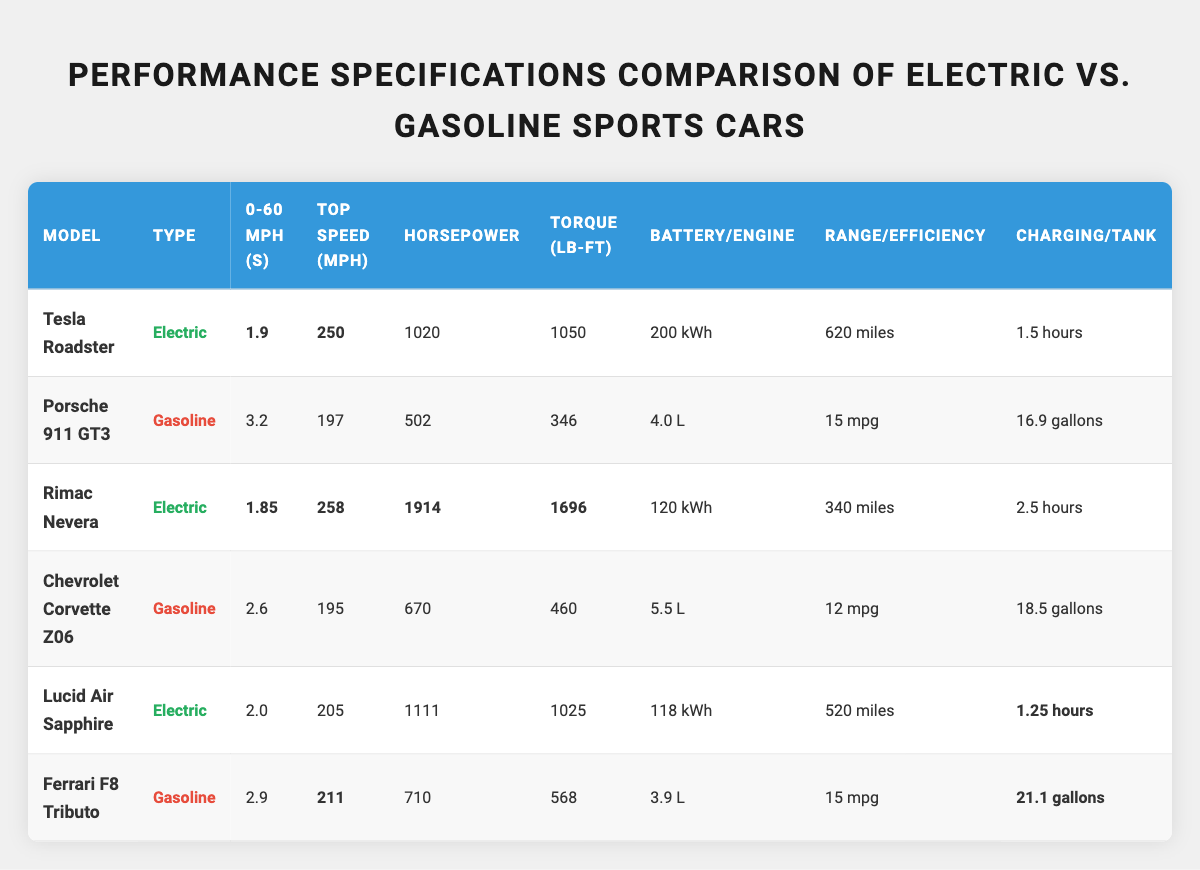What is the fastest 0-60 mph time among the cars? The table lists the 0-60 mph times for each model. The fastest time is for the Tesla Roadster at 1.9 seconds, followed closely by the Rimac Nevera at 1.85 seconds. Therefore, the fastest 0-60 mph time is 1.85 seconds.
Answer: 1.85 seconds Which car has the highest horsepower? By reviewing the horsepower values in the table, the Rimac Nevera has the highest horsepower at 1914. This is higher than the horsepower values of the Tesla Roadster (1020), Porsche 911 GT3 (502), Chevrolet Corvette Z06 (670), Lucid Air Sapphire (1111), and Ferrari F8 Tributo (710).
Answer: 1914 horsepower What is the torque difference between the Rimac Nevera and the Tesla Roadster? The Rimac Nevera has a torque of 1696 lb-ft, while the Tesla Roadster has a torque of 1050 lb-ft. To find the difference, subtract 1050 from 1696: 1696 - 1050 = 646.
Answer: 646 lb-ft Which type of car has the better range, electric or gasoline? Electric cars in the table, such as the Tesla Roadster (620 miles) and Lucid Air Sapphire (520 miles), have longer ranges compared to gasoline cars like Porsche 911 GT3 (15 mpg), Chevrolet Corvette Z06 (12 mpg), and Ferrari F8 Tributo (15 mpg), which do not have comparable range values.
Answer: Electric cars have better range What is the average 0-60 mph time of gasoline cars? The gasoline cars' 0-60 mph times are 3.2 seconds (Porsche 911 GT3), 2.6 seconds (Chevrolet Corvette Z06), and 2.9 seconds (Ferrari F8 Tributo). To find the average, sum these times (3.2 + 2.6 + 2.9 = 8.7) and divide by the number of cars (3): 8.7 / 3 = 2.9 seconds.
Answer: 2.9 seconds Which car has the shortest charging time? Reviewing the charging times in the table, the Lucid Air Sapphire has the shortest charging time of 1.25 hours, which is less than the Tesla Roadster's 1.5 hours and the Rimac Nevera's 2.5 hours.
Answer: 1.25 hours Is the top speed of the Rimac Nevera higher than that of the Chevrolet Corvette Z06? The top speed of the Rimac Nevera is 258 mph, while the Chevrolet Corvette Z06 has a top speed of 195 mph. Since 258 is greater than 195, the answer is yes.
Answer: Yes How much more torque does the Lucid Air Sapphire have compared to the Porsche 911 GT3? The torque of the Lucid Air Sapphire is 1025 lb-ft, and that of the Porsche 911 GT3 is 346 lb-ft. The difference in torque is 1025 - 346 = 679 lb-ft.
Answer: 679 lb-ft If we categorize cars into electric and gasoline, how many of each type are there? There are 3 electric cars (Tesla Roadster, Rimac Nevera, Lucid Air Sapphire) and 3 gasoline cars (Porsche 911 GT3, Chevrolet Corvette Z06, Ferrari F8 Tributo) in the table.
Answer: 3 electric and 3 gasoline cars What is the range of the vehicle with the highest battery capacity? The vehicle with the highest battery capacity is the Tesla Roadster at 200 kWh, which has a range of 620 miles. Therefore, the range of this vehicle is 620 miles.
Answer: 620 miles Is the fuel efficiency of the Ferrari F8 Tributo higher than that of the Chevrolet Corvette Z06? The Ferrari F8 Tributo has a fuel efficiency of 15 mpg, while the Chevrolet Corvette Z06 has a fuel efficiency of 12 mpg. Since 15 is greater than 12, the answer is yes.
Answer: Yes 